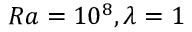<formula> <loc_0><loc_0><loc_500><loc_500>R a = 1 0 ^ { 8 } , \lambda = 1</formula> 